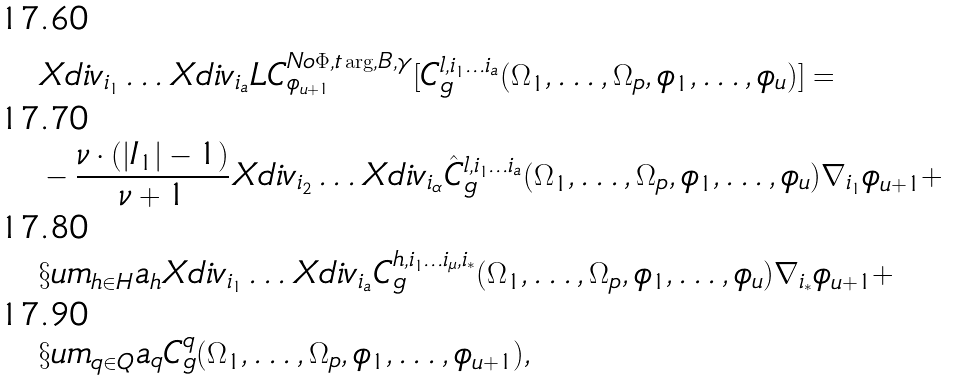<formula> <loc_0><loc_0><loc_500><loc_500>& X d i v _ { i _ { 1 } } \dots X d i v _ { i _ { a } } L C ^ { N o \Phi , t \arg , B , \gamma } _ { \phi _ { u + 1 } } [ C ^ { l , i _ { 1 } \dots i _ { a } } _ { g } ( \Omega _ { 1 } , \dots , \Omega _ { p } , \phi _ { 1 } , \dots , \phi _ { u } ) ] = \\ & - \frac { \nu \cdot ( | I _ { 1 } | - 1 ) } { \nu + 1 } X d i v _ { i _ { 2 } } \dots X d i v _ { i _ { \alpha } } \hat { C } ^ { l , i _ { 1 } \dots i _ { a } } _ { g } ( \Omega _ { 1 } , \dots , \Omega _ { p } , \phi _ { 1 } , \dots , \phi _ { u } ) \nabla _ { i _ { 1 } } \phi _ { u + 1 } + \\ & \S u m _ { h \in H } a _ { h } X d i v _ { i _ { 1 } } \dots X d i v _ { i _ { a } } C ^ { h , i _ { 1 } \dots i _ { \mu } , i _ { * } } _ { g } ( \Omega _ { 1 } , \dots , \Omega _ { p } , \phi _ { 1 } , \dots , \phi _ { u } ) \nabla _ { i _ { * } } \phi _ { u + 1 } + \\ & \S u m _ { q \in Q } a _ { q } C ^ { q } _ { g } ( \Omega _ { 1 } , \dots , \Omega _ { p } , \phi _ { 1 } , \dots , \phi _ { u + 1 } ) ,</formula> 